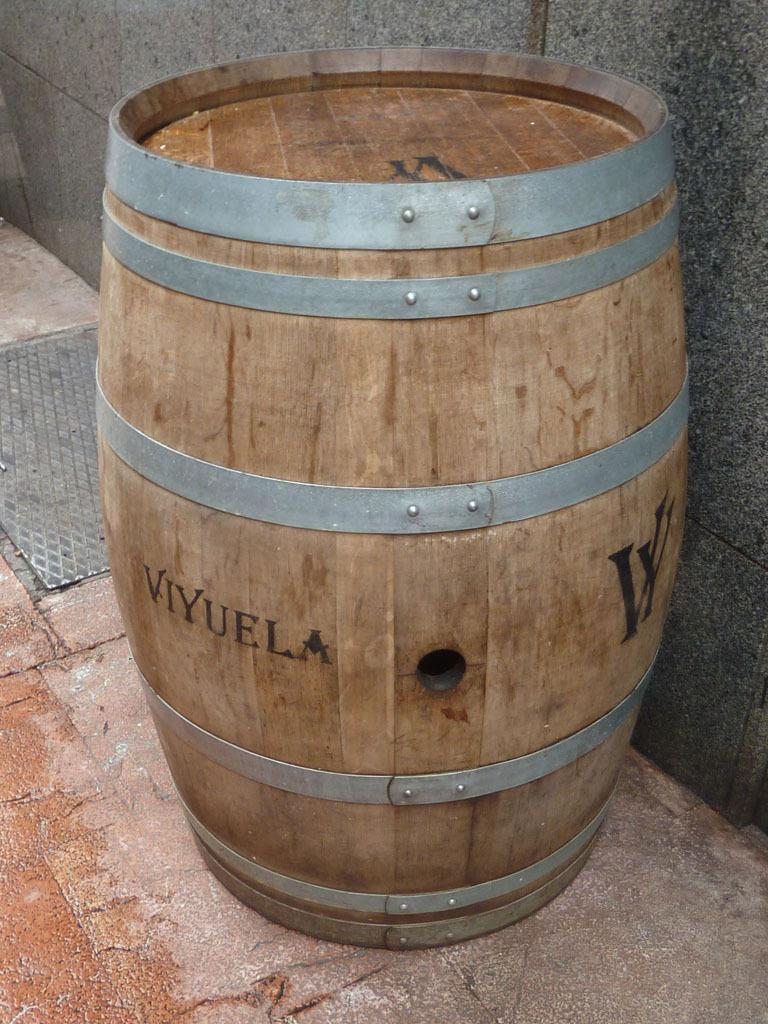What type of container is present in the image? There is a wooden barrel in the image. What can be seen on the surface of the wooden barrel? The wooden barrel has text on its surface. What is visible in the background of the image? There is a wall in the background of the image. What is located on the left side of the image? There is a steel lid on the left side of the image. What type of sofa is depicted in the image? There is no sofa present in the image; it features a wooden barrel with text and a steel lid. What is the stem of the plant in the image? There is no plant or stem present in the image. 